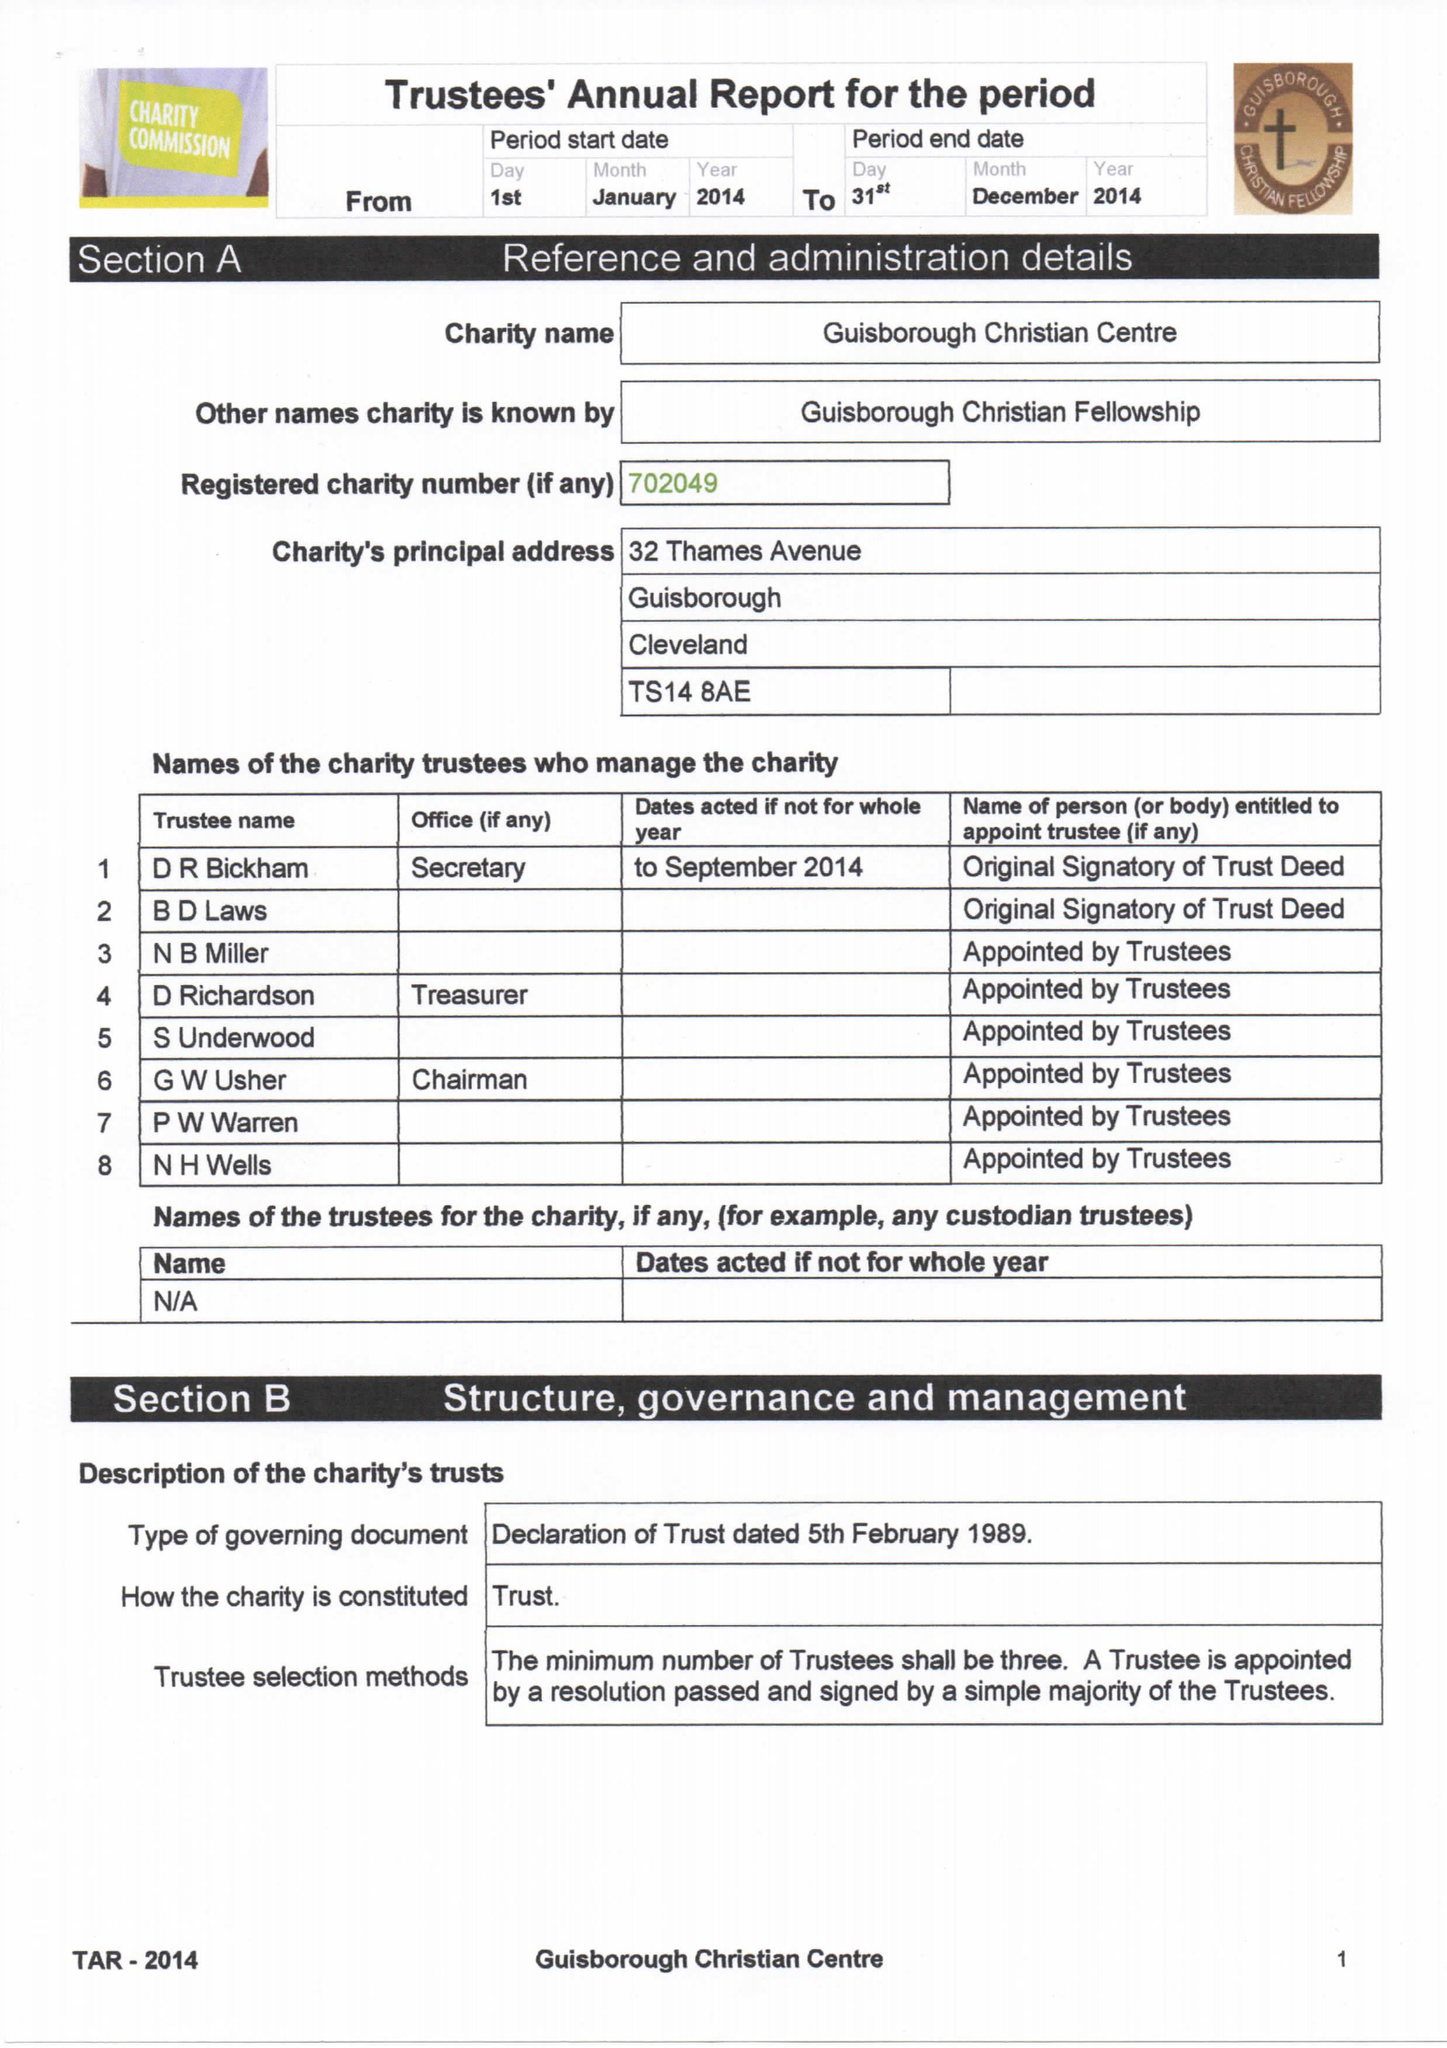What is the value for the charity_name?
Answer the question using a single word or phrase. Guisborough Christian Centre 